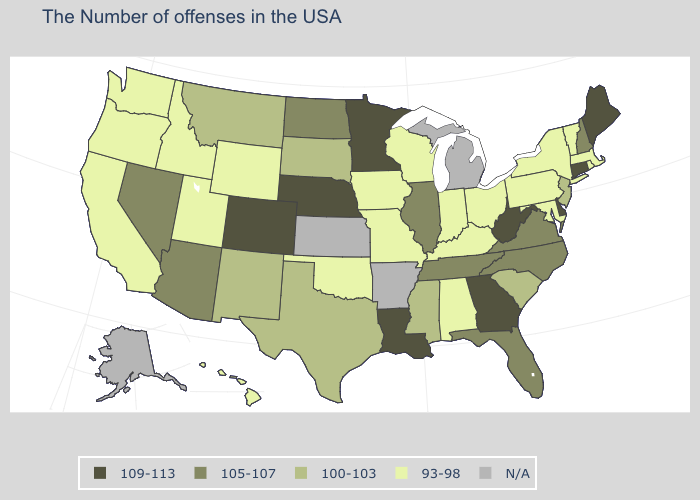What is the lowest value in the USA?
Keep it brief. 93-98. What is the value of Wisconsin?
Be succinct. 93-98. What is the value of New Mexico?
Quick response, please. 100-103. Does Indiana have the highest value in the MidWest?
Concise answer only. No. Does the map have missing data?
Write a very short answer. Yes. Which states have the lowest value in the USA?
Short answer required. Massachusetts, Rhode Island, Vermont, New York, Maryland, Pennsylvania, Ohio, Kentucky, Indiana, Alabama, Wisconsin, Missouri, Iowa, Oklahoma, Wyoming, Utah, Idaho, California, Washington, Oregon, Hawaii. Does Florida have the lowest value in the South?
Concise answer only. No. Name the states that have a value in the range N/A?
Be succinct. Michigan, Arkansas, Kansas, Alaska. Does New Hampshire have the lowest value in the Northeast?
Concise answer only. No. Which states have the lowest value in the MidWest?
Write a very short answer. Ohio, Indiana, Wisconsin, Missouri, Iowa. What is the value of Illinois?
Give a very brief answer. 105-107. What is the value of Illinois?
Short answer required. 105-107. What is the value of Florida?
Answer briefly. 105-107. 